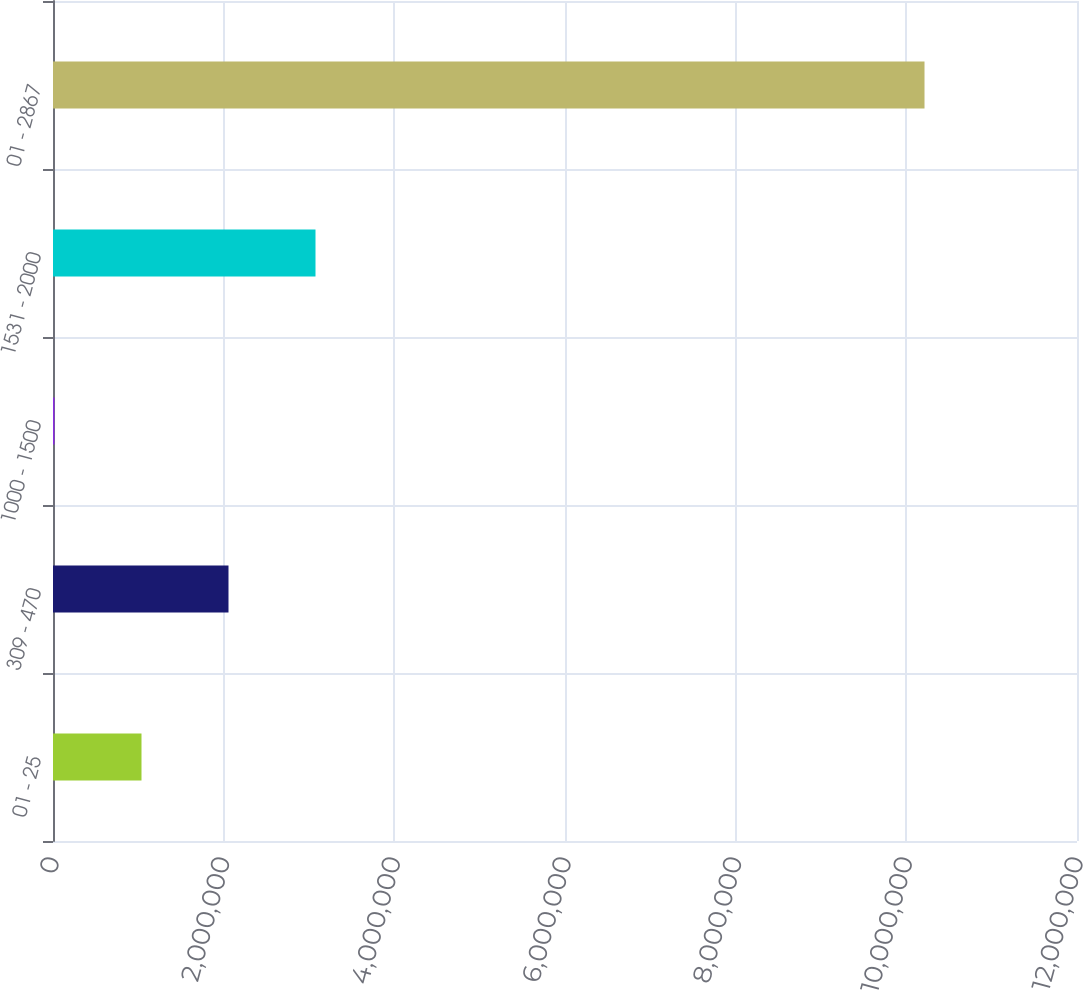Convert chart to OTSL. <chart><loc_0><loc_0><loc_500><loc_500><bar_chart><fcel>01 - 25<fcel>309 - 470<fcel>1000 - 1500<fcel>1531 - 2000<fcel>01 - 2867<nl><fcel>1.03705e+06<fcel>2.0566e+06<fcel>17500<fcel>3.07615e+06<fcel>1.0213e+07<nl></chart> 